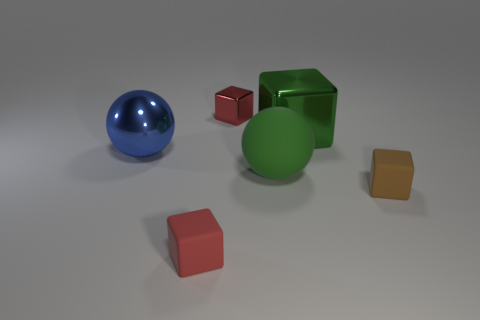Do the large metal thing on the left side of the big green matte object and the small object on the right side of the green block have the same shape?
Offer a very short reply. No. How many objects are big purple metal blocks or matte objects left of the green block?
Give a very brief answer. 2. There is a thing that is on the left side of the tiny shiny object and to the right of the big blue object; what material is it made of?
Offer a terse response. Rubber. Is there anything else that is the same shape as the big rubber thing?
Keep it short and to the point. Yes. There is another cube that is the same material as the brown block; what color is it?
Give a very brief answer. Red. How many objects are tiny red matte objects or large shiny cubes?
Provide a succinct answer. 2. There is a brown thing; does it have the same size as the red thing that is in front of the brown cube?
Make the answer very short. Yes. What color is the thing that is right of the metal cube that is right of the small red object behind the blue thing?
Provide a succinct answer. Brown. The big metallic sphere is what color?
Your response must be concise. Blue. Is the number of balls in front of the blue metal object greater than the number of tiny metallic things in front of the green rubber thing?
Ensure brevity in your answer.  Yes. 